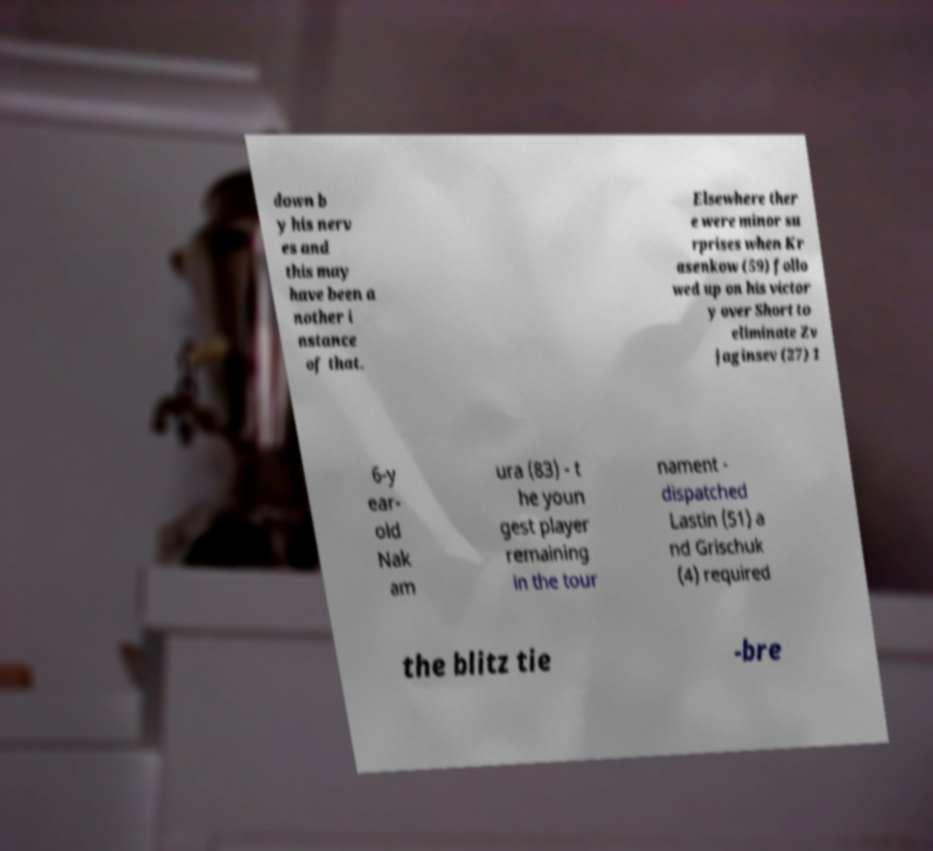What messages or text are displayed in this image? I need them in a readable, typed format. down b y his nerv es and this may have been a nother i nstance of that. Elsewhere ther e were minor su rprises when Kr asenkow (59) follo wed up on his victor y over Short to eliminate Zv jaginsev (27) 1 6-y ear- old Nak am ura (83) - t he youn gest player remaining in the tour nament - dispatched Lastin (51) a nd Grischuk (4) required the blitz tie -bre 